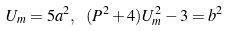<formula> <loc_0><loc_0><loc_500><loc_500>U _ { m } = 5 a ^ { 2 } , \text { } ( P ^ { 2 } + 4 ) U _ { m } ^ { 2 } - 3 = b ^ { 2 }</formula> 